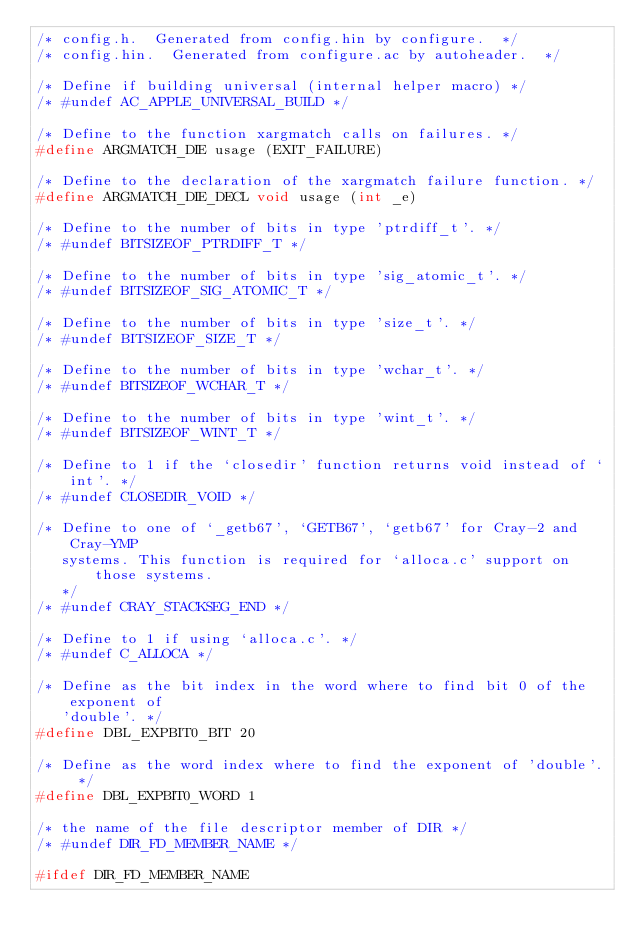Convert code to text. <code><loc_0><loc_0><loc_500><loc_500><_C_>/* config.h.  Generated from config.hin by configure.  */
/* config.hin.  Generated from configure.ac by autoheader.  */

/* Define if building universal (internal helper macro) */
/* #undef AC_APPLE_UNIVERSAL_BUILD */

/* Define to the function xargmatch calls on failures. */
#define ARGMATCH_DIE usage (EXIT_FAILURE)

/* Define to the declaration of the xargmatch failure function. */
#define ARGMATCH_DIE_DECL void usage (int _e)

/* Define to the number of bits in type 'ptrdiff_t'. */
/* #undef BITSIZEOF_PTRDIFF_T */

/* Define to the number of bits in type 'sig_atomic_t'. */
/* #undef BITSIZEOF_SIG_ATOMIC_T */

/* Define to the number of bits in type 'size_t'. */
/* #undef BITSIZEOF_SIZE_T */

/* Define to the number of bits in type 'wchar_t'. */
/* #undef BITSIZEOF_WCHAR_T */

/* Define to the number of bits in type 'wint_t'. */
/* #undef BITSIZEOF_WINT_T */

/* Define to 1 if the `closedir' function returns void instead of `int'. */
/* #undef CLOSEDIR_VOID */

/* Define to one of `_getb67', `GETB67', `getb67' for Cray-2 and Cray-YMP
   systems. This function is required for `alloca.c' support on those systems.
   */
/* #undef CRAY_STACKSEG_END */

/* Define to 1 if using `alloca.c'. */
/* #undef C_ALLOCA */

/* Define as the bit index in the word where to find bit 0 of the exponent of
   'double'. */
#define DBL_EXPBIT0_BIT 20

/* Define as the word index where to find the exponent of 'double'. */
#define DBL_EXPBIT0_WORD 1

/* the name of the file descriptor member of DIR */
/* #undef DIR_FD_MEMBER_NAME */

#ifdef DIR_FD_MEMBER_NAME</code> 